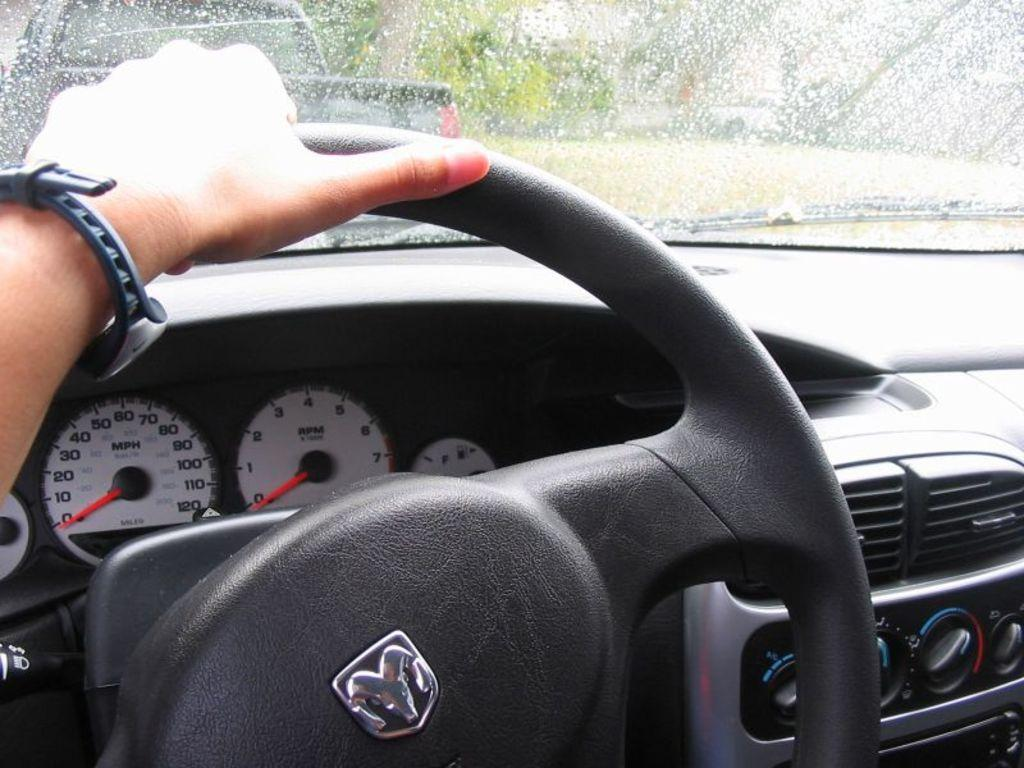What is the main subject of the image? There is a person in the image. What is the person doing in the image? The person has his hands on a steering wheel. What else can be seen in the image besides the person? There are other objects beside the person. What is visible in the background of the image? There are other vehicles in the background of the image. What type of bubble is floating near the person in the image? There is no bubble present in the image. What material is the brass used for in the image? There is no brass present in the image. 